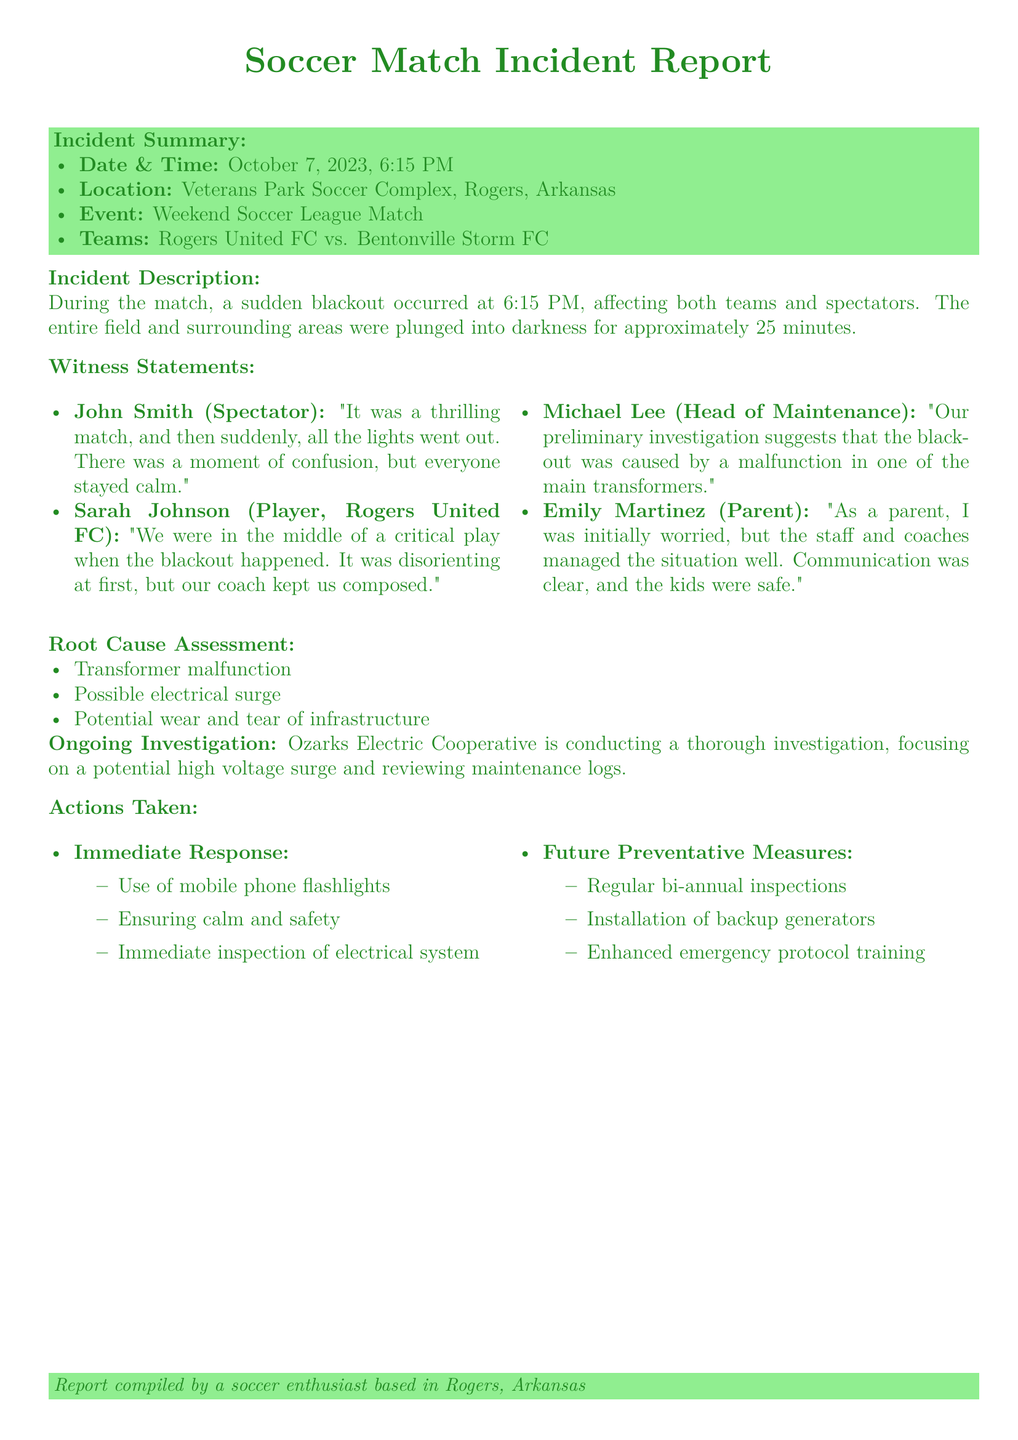What was the date of the incident? The date of the incident is mentioned in the incident summary as October 7, 2023.
Answer: October 7, 2023 How long did the blackout last? The document states that the blackout lasted for approximately 25 minutes.
Answer: 25 minutes Who were the teams involved in the match? The teams are listed in the incident summary as Rogers United FC and Bentonville Storm FC.
Answer: Rogers United FC vs. Bentonville Storm FC What was the root cause of the blackout according to the maintenance head? Michael Lee indicated that the preliminary investigation suggests a malfunction in one of the main transformers.
Answer: Malfunction in one of the main transformers What actions were taken for future prevention? Future preventative measures include regular bi-annual inspections, installation of backup generators, and enhanced emergency protocol training.
Answer: Regular bi-annual inspections What was the immediate response during the blackout? The immediate response included the use of mobile phone flashlights, ensuring calm and safety, and immediate inspection of the electrical system.
Answer: Use of mobile phone flashlights How many witness statements are included in the report? The document lists four witness statements in the section provided.
Answer: Four Which organization is conducting the ongoing investigation? The report states that Ozarks Electric Cooperative is conducting a thorough investigation.
Answer: Ozarks Electric Cooperative 